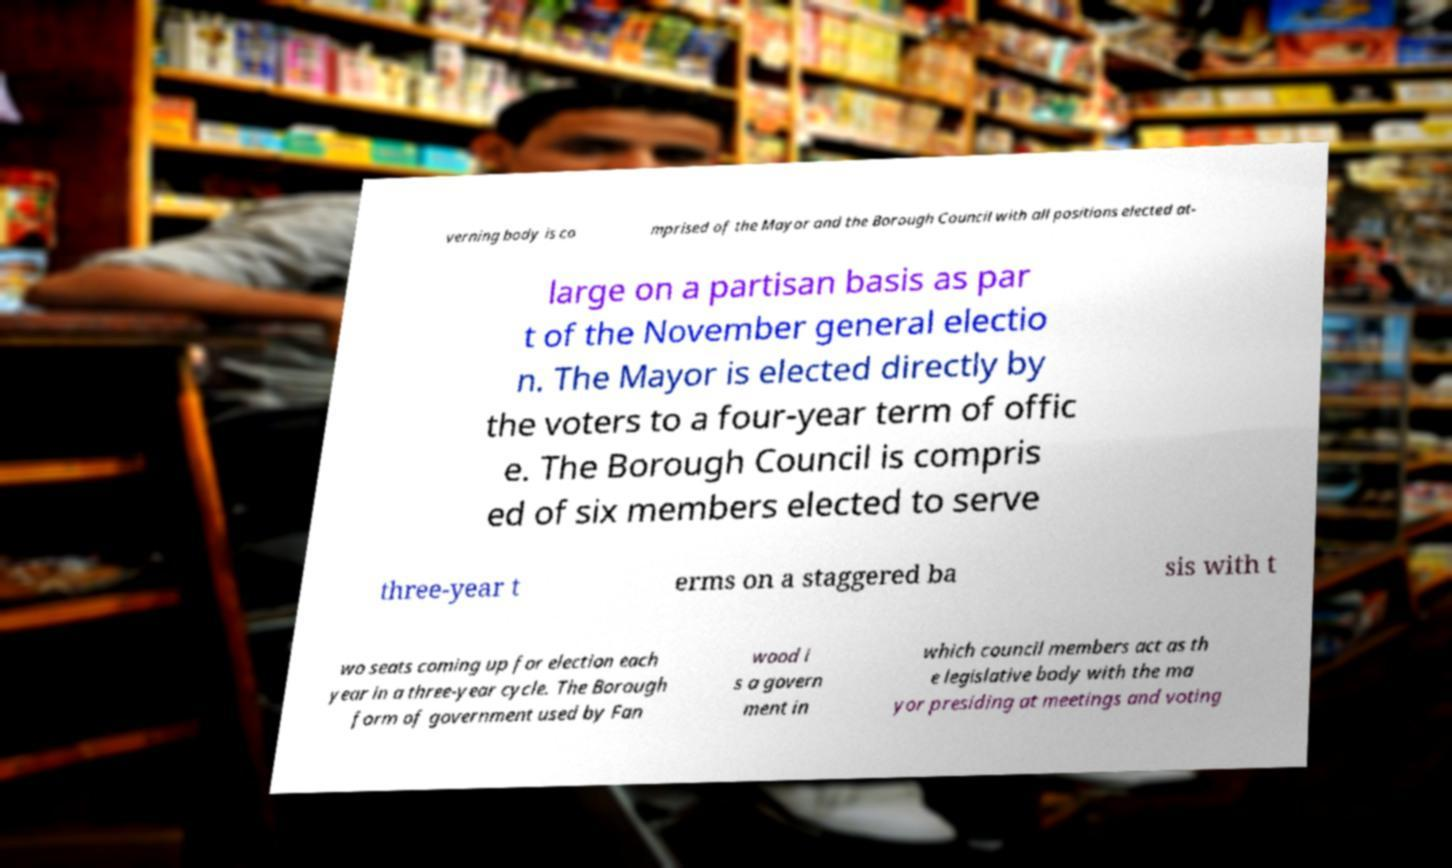I need the written content from this picture converted into text. Can you do that? verning body is co mprised of the Mayor and the Borough Council with all positions elected at- large on a partisan basis as par t of the November general electio n. The Mayor is elected directly by the voters to a four-year term of offic e. The Borough Council is compris ed of six members elected to serve three-year t erms on a staggered ba sis with t wo seats coming up for election each year in a three-year cycle. The Borough form of government used by Fan wood i s a govern ment in which council members act as th e legislative body with the ma yor presiding at meetings and voting 